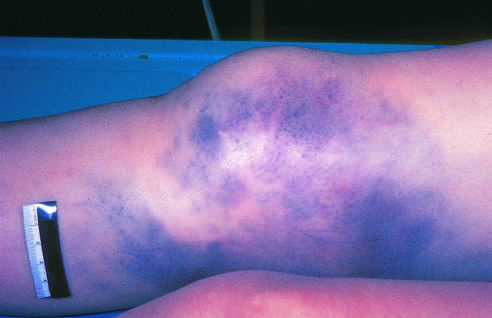what is intact?
Answer the question using a single word or phrase. The skin 